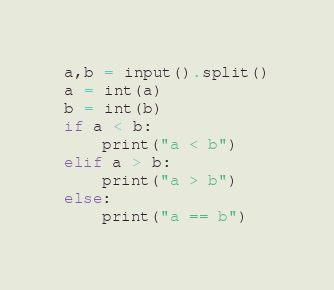Convert code to text. <code><loc_0><loc_0><loc_500><loc_500><_Python_>a,b = input().split()
a = int(a)
b = int(b)
if a < b:
    print("a < b")
elif a > b:
    print("a > b")
else:
    print("a == b")
</code> 